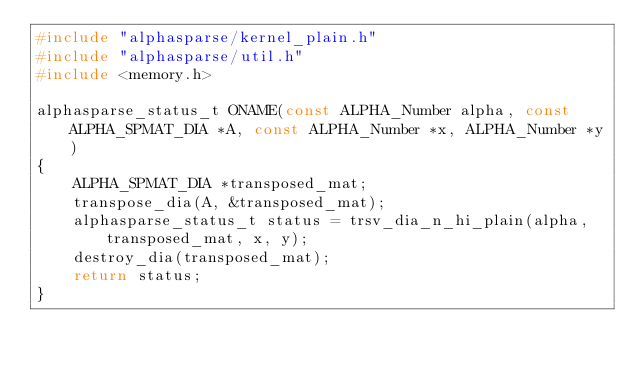Convert code to text. <code><loc_0><loc_0><loc_500><loc_500><_C_>#include "alphasparse/kernel_plain.h"
#include "alphasparse/util.h"
#include <memory.h>

alphasparse_status_t ONAME(const ALPHA_Number alpha, const ALPHA_SPMAT_DIA *A, const ALPHA_Number *x, ALPHA_Number *y)
{
    ALPHA_SPMAT_DIA *transposed_mat;
    transpose_dia(A, &transposed_mat);
    alphasparse_status_t status = trsv_dia_n_hi_plain(alpha, transposed_mat, x, y);
    destroy_dia(transposed_mat);
    return status;
}
</code> 